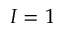Convert formula to latex. <formula><loc_0><loc_0><loc_500><loc_500>I = 1</formula> 